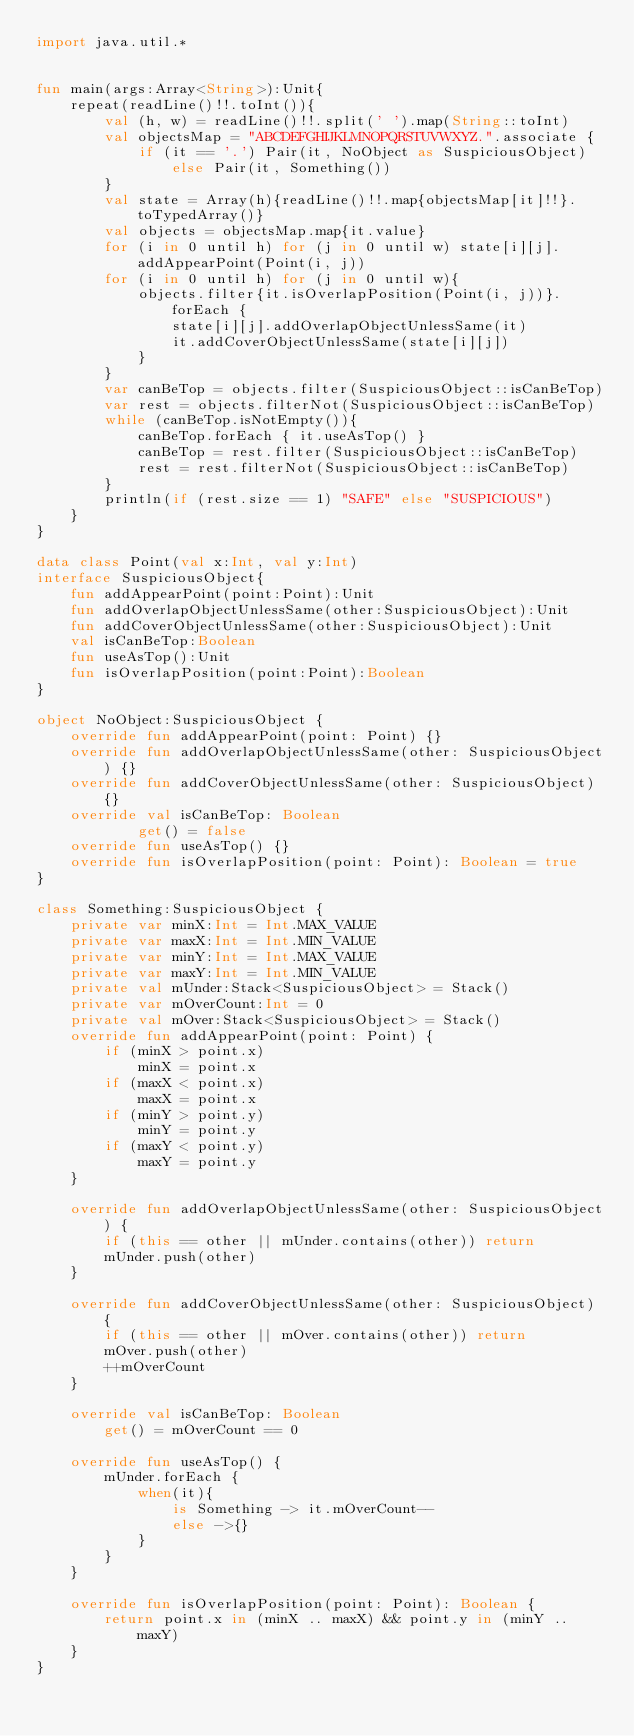<code> <loc_0><loc_0><loc_500><loc_500><_Kotlin_>import java.util.*


fun main(args:Array<String>):Unit{
    repeat(readLine()!!.toInt()){
        val (h, w) = readLine()!!.split(' ').map(String::toInt)
        val objectsMap = "ABCDEFGHIJKLMNOPQRSTUVWXYZ.".associate {
            if (it == '.') Pair(it, NoObject as SuspiciousObject) else Pair(it, Something())
        }
        val state = Array(h){readLine()!!.map{objectsMap[it]!!}.toTypedArray()}
        val objects = objectsMap.map{it.value}
        for (i in 0 until h) for (j in 0 until w) state[i][j].addAppearPoint(Point(i, j))
        for (i in 0 until h) for (j in 0 until w){
            objects.filter{it.isOverlapPosition(Point(i, j))}.forEach {
                state[i][j].addOverlapObjectUnlessSame(it)
                it.addCoverObjectUnlessSame(state[i][j])
            }
        }
        var canBeTop = objects.filter(SuspiciousObject::isCanBeTop)
        var rest = objects.filterNot(SuspiciousObject::isCanBeTop)
        while (canBeTop.isNotEmpty()){
            canBeTop.forEach { it.useAsTop() }
            canBeTop = rest.filter(SuspiciousObject::isCanBeTop)
            rest = rest.filterNot(SuspiciousObject::isCanBeTop)
        }
        println(if (rest.size == 1) "SAFE" else "SUSPICIOUS")
    }
}

data class Point(val x:Int, val y:Int)
interface SuspiciousObject{
    fun addAppearPoint(point:Point):Unit
    fun addOverlapObjectUnlessSame(other:SuspiciousObject):Unit
    fun addCoverObjectUnlessSame(other:SuspiciousObject):Unit
    val isCanBeTop:Boolean
    fun useAsTop():Unit
    fun isOverlapPosition(point:Point):Boolean
}

object NoObject:SuspiciousObject {
    override fun addAppearPoint(point: Point) {}
    override fun addOverlapObjectUnlessSame(other: SuspiciousObject) {}
    override fun addCoverObjectUnlessSame(other: SuspiciousObject) {}
    override val isCanBeTop: Boolean
            get() = false
    override fun useAsTop() {}
    override fun isOverlapPosition(point: Point): Boolean = true
}

class Something:SuspiciousObject {
    private var minX:Int = Int.MAX_VALUE
    private var maxX:Int = Int.MIN_VALUE
    private var minY:Int = Int.MAX_VALUE
    private var maxY:Int = Int.MIN_VALUE
    private val mUnder:Stack<SuspiciousObject> = Stack()
    private var mOverCount:Int = 0
    private val mOver:Stack<SuspiciousObject> = Stack()
    override fun addAppearPoint(point: Point) {
        if (minX > point.x)
            minX = point.x
        if (maxX < point.x)
            maxX = point.x
        if (minY > point.y)
            minY = point.y
        if (maxY < point.y)
            maxY = point.y
    }

    override fun addOverlapObjectUnlessSame(other: SuspiciousObject) {
        if (this == other || mUnder.contains(other)) return
        mUnder.push(other)
    }

    override fun addCoverObjectUnlessSame(other: SuspiciousObject) {
        if (this == other || mOver.contains(other)) return
        mOver.push(other)
        ++mOverCount
    }

    override val isCanBeTop: Boolean
        get() = mOverCount == 0

    override fun useAsTop() {
        mUnder.forEach {
            when(it){
                is Something -> it.mOverCount--
                else ->{}
            }
        }
    }

    override fun isOverlapPosition(point: Point): Boolean {
        return point.x in (minX .. maxX) && point.y in (minY .. maxY)
    }
}
</code> 